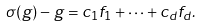Convert formula to latex. <formula><loc_0><loc_0><loc_500><loc_500>\sigma ( g ) - g = c _ { 1 } f _ { 1 } + \dots + c _ { d } f _ { d } .</formula> 